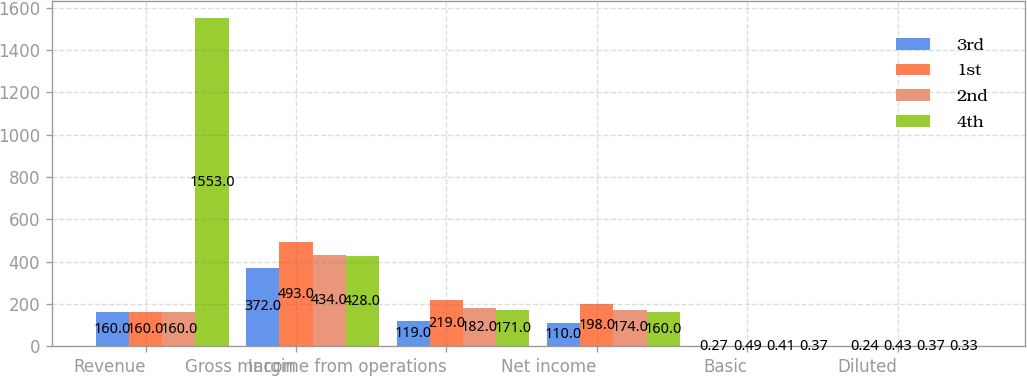<chart> <loc_0><loc_0><loc_500><loc_500><stacked_bar_chart><ecel><fcel>Revenue<fcel>Gross margin<fcel>Income from operations<fcel>Net income<fcel>Basic<fcel>Diluted<nl><fcel>3rd<fcel>160<fcel>372<fcel>119<fcel>110<fcel>0.27<fcel>0.24<nl><fcel>1st<fcel>160<fcel>493<fcel>219<fcel>198<fcel>0.49<fcel>0.43<nl><fcel>2nd<fcel>160<fcel>434<fcel>182<fcel>174<fcel>0.41<fcel>0.37<nl><fcel>4th<fcel>1553<fcel>428<fcel>171<fcel>160<fcel>0.37<fcel>0.33<nl></chart> 